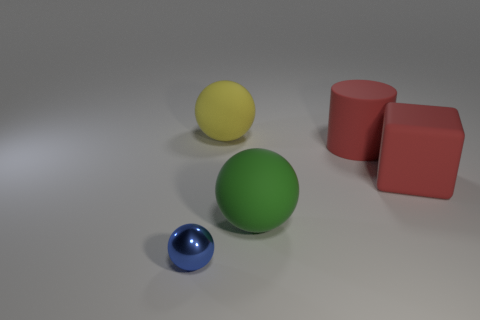Add 1 balls. How many objects exist? 6 Subtract all cylinders. How many objects are left? 4 Add 5 big yellow rubber things. How many big yellow rubber things are left? 6 Add 1 small yellow matte blocks. How many small yellow matte blocks exist? 1 Subtract 0 purple cubes. How many objects are left? 5 Subtract all matte balls. Subtract all large red matte things. How many objects are left? 1 